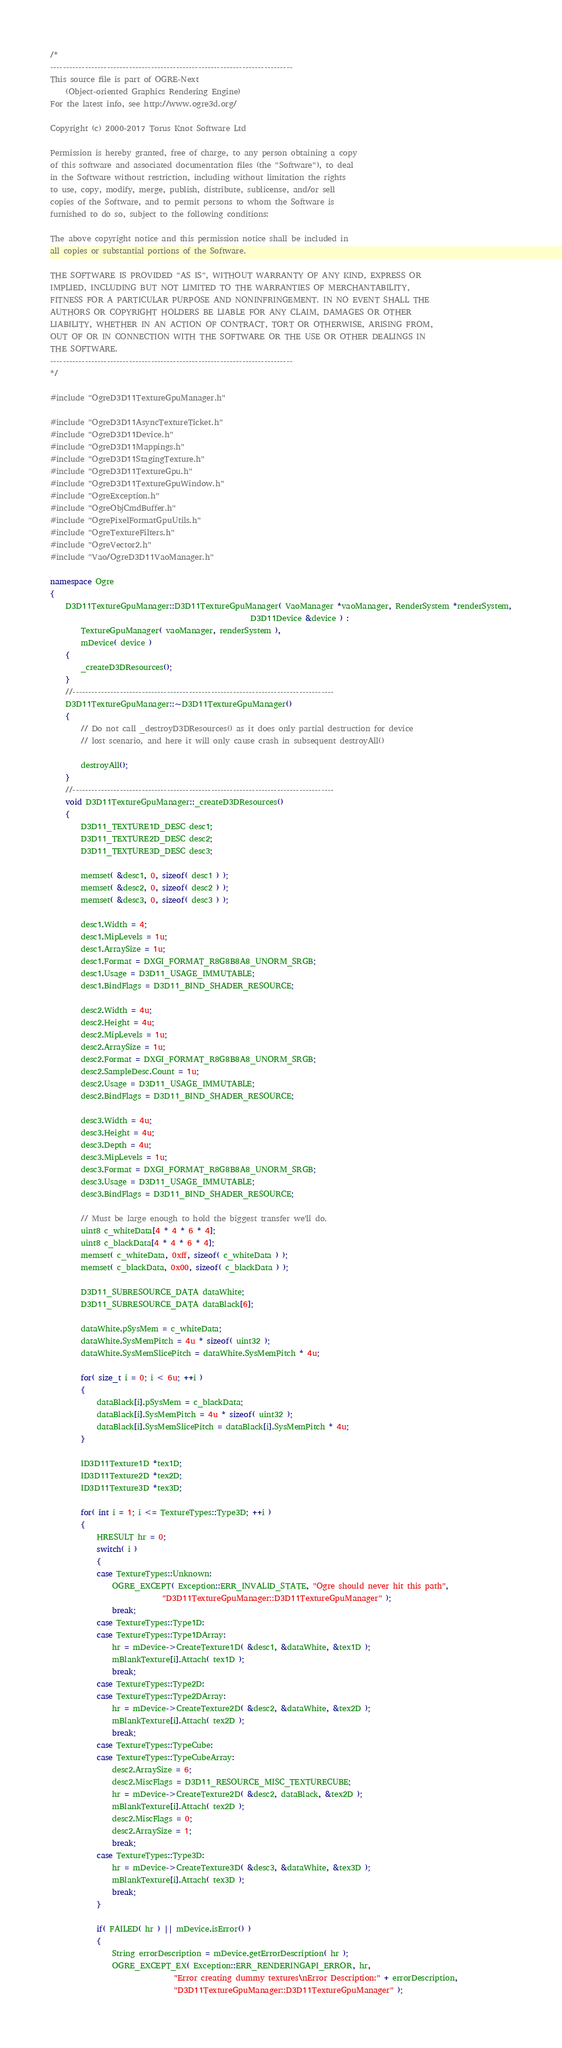<code> <loc_0><loc_0><loc_500><loc_500><_C++_>/*
-----------------------------------------------------------------------------
This source file is part of OGRE-Next
    (Object-oriented Graphics Rendering Engine)
For the latest info, see http://www.ogre3d.org/

Copyright (c) 2000-2017 Torus Knot Software Ltd

Permission is hereby granted, free of charge, to any person obtaining a copy
of this software and associated documentation files (the "Software"), to deal
in the Software without restriction, including without limitation the rights
to use, copy, modify, merge, publish, distribute, sublicense, and/or sell
copies of the Software, and to permit persons to whom the Software is
furnished to do so, subject to the following conditions:

The above copyright notice and this permission notice shall be included in
all copies or substantial portions of the Software.

THE SOFTWARE IS PROVIDED "AS IS", WITHOUT WARRANTY OF ANY KIND, EXPRESS OR
IMPLIED, INCLUDING BUT NOT LIMITED TO THE WARRANTIES OF MERCHANTABILITY,
FITNESS FOR A PARTICULAR PURPOSE AND NONINFRINGEMENT. IN NO EVENT SHALL THE
AUTHORS OR COPYRIGHT HOLDERS BE LIABLE FOR ANY CLAIM, DAMAGES OR OTHER
LIABILITY, WHETHER IN AN ACTION OF CONTRACT, TORT OR OTHERWISE, ARISING FROM,
OUT OF OR IN CONNECTION WITH THE SOFTWARE OR THE USE OR OTHER DEALINGS IN
THE SOFTWARE.
-----------------------------------------------------------------------------
*/

#include "OgreD3D11TextureGpuManager.h"

#include "OgreD3D11AsyncTextureTicket.h"
#include "OgreD3D11Device.h"
#include "OgreD3D11Mappings.h"
#include "OgreD3D11StagingTexture.h"
#include "OgreD3D11TextureGpu.h"
#include "OgreD3D11TextureGpuWindow.h"
#include "OgreException.h"
#include "OgreObjCmdBuffer.h"
#include "OgrePixelFormatGpuUtils.h"
#include "OgreTextureFilters.h"
#include "OgreVector2.h"
#include "Vao/OgreD3D11VaoManager.h"

namespace Ogre
{
    D3D11TextureGpuManager::D3D11TextureGpuManager( VaoManager *vaoManager, RenderSystem *renderSystem,
                                                    D3D11Device &device ) :
        TextureGpuManager( vaoManager, renderSystem ),
        mDevice( device )
    {
        _createD3DResources();
    }
    //-----------------------------------------------------------------------------------
    D3D11TextureGpuManager::~D3D11TextureGpuManager()
    {
        // Do not call _destroyD3DResources() as it does only partial destruction for device
        // lost scenario, and here it will only cause crash in subsequent destroyAll()

        destroyAll();
    }
    //-----------------------------------------------------------------------------------
    void D3D11TextureGpuManager::_createD3DResources()
    {
        D3D11_TEXTURE1D_DESC desc1;
        D3D11_TEXTURE2D_DESC desc2;
        D3D11_TEXTURE3D_DESC desc3;

        memset( &desc1, 0, sizeof( desc1 ) );
        memset( &desc2, 0, sizeof( desc2 ) );
        memset( &desc3, 0, sizeof( desc3 ) );

        desc1.Width = 4;
        desc1.MipLevels = 1u;
        desc1.ArraySize = 1u;
        desc1.Format = DXGI_FORMAT_R8G8B8A8_UNORM_SRGB;
        desc1.Usage = D3D11_USAGE_IMMUTABLE;
        desc1.BindFlags = D3D11_BIND_SHADER_RESOURCE;

        desc2.Width = 4u;
        desc2.Height = 4u;
        desc2.MipLevels = 1u;
        desc2.ArraySize = 1u;
        desc2.Format = DXGI_FORMAT_R8G8B8A8_UNORM_SRGB;
        desc2.SampleDesc.Count = 1u;
        desc2.Usage = D3D11_USAGE_IMMUTABLE;
        desc2.BindFlags = D3D11_BIND_SHADER_RESOURCE;

        desc3.Width = 4u;
        desc3.Height = 4u;
        desc3.Depth = 4u;
        desc3.MipLevels = 1u;
        desc3.Format = DXGI_FORMAT_R8G8B8A8_UNORM_SRGB;
        desc3.Usage = D3D11_USAGE_IMMUTABLE;
        desc3.BindFlags = D3D11_BIND_SHADER_RESOURCE;

        // Must be large enough to hold the biggest transfer we'll do.
        uint8 c_whiteData[4 * 4 * 6 * 4];
        uint8 c_blackData[4 * 4 * 6 * 4];
        memset( c_whiteData, 0xff, sizeof( c_whiteData ) );
        memset( c_blackData, 0x00, sizeof( c_blackData ) );

        D3D11_SUBRESOURCE_DATA dataWhite;
        D3D11_SUBRESOURCE_DATA dataBlack[6];

        dataWhite.pSysMem = c_whiteData;
        dataWhite.SysMemPitch = 4u * sizeof( uint32 );
        dataWhite.SysMemSlicePitch = dataWhite.SysMemPitch * 4u;

        for( size_t i = 0; i < 6u; ++i )
        {
            dataBlack[i].pSysMem = c_blackData;
            dataBlack[i].SysMemPitch = 4u * sizeof( uint32 );
            dataBlack[i].SysMemSlicePitch = dataBlack[i].SysMemPitch * 4u;
        }

        ID3D11Texture1D *tex1D;
        ID3D11Texture2D *tex2D;
        ID3D11Texture3D *tex3D;

        for( int i = 1; i <= TextureTypes::Type3D; ++i )
        {
            HRESULT hr = 0;
            switch( i )
            {
            case TextureTypes::Unknown:
                OGRE_EXCEPT( Exception::ERR_INVALID_STATE, "Ogre should never hit this path",
                             "D3D11TextureGpuManager::D3D11TextureGpuManager" );
                break;
            case TextureTypes::Type1D:
            case TextureTypes::Type1DArray:
                hr = mDevice->CreateTexture1D( &desc1, &dataWhite, &tex1D );
                mBlankTexture[i].Attach( tex1D );
                break;
            case TextureTypes::Type2D:
            case TextureTypes::Type2DArray:
                hr = mDevice->CreateTexture2D( &desc2, &dataWhite, &tex2D );
                mBlankTexture[i].Attach( tex2D );
                break;
            case TextureTypes::TypeCube:
            case TextureTypes::TypeCubeArray:
                desc2.ArraySize = 6;
                desc2.MiscFlags = D3D11_RESOURCE_MISC_TEXTURECUBE;
                hr = mDevice->CreateTexture2D( &desc2, dataBlack, &tex2D );
                mBlankTexture[i].Attach( tex2D );
                desc2.MiscFlags = 0;
                desc2.ArraySize = 1;
                break;
            case TextureTypes::Type3D:
                hr = mDevice->CreateTexture3D( &desc3, &dataWhite, &tex3D );
                mBlankTexture[i].Attach( tex3D );
                break;
            }

            if( FAILED( hr ) || mDevice.isError() )
            {
                String errorDescription = mDevice.getErrorDescription( hr );
                OGRE_EXCEPT_EX( Exception::ERR_RENDERINGAPI_ERROR, hr,
                                "Error creating dummy textures\nError Description:" + errorDescription,
                                "D3D11TextureGpuManager::D3D11TextureGpuManager" );</code> 